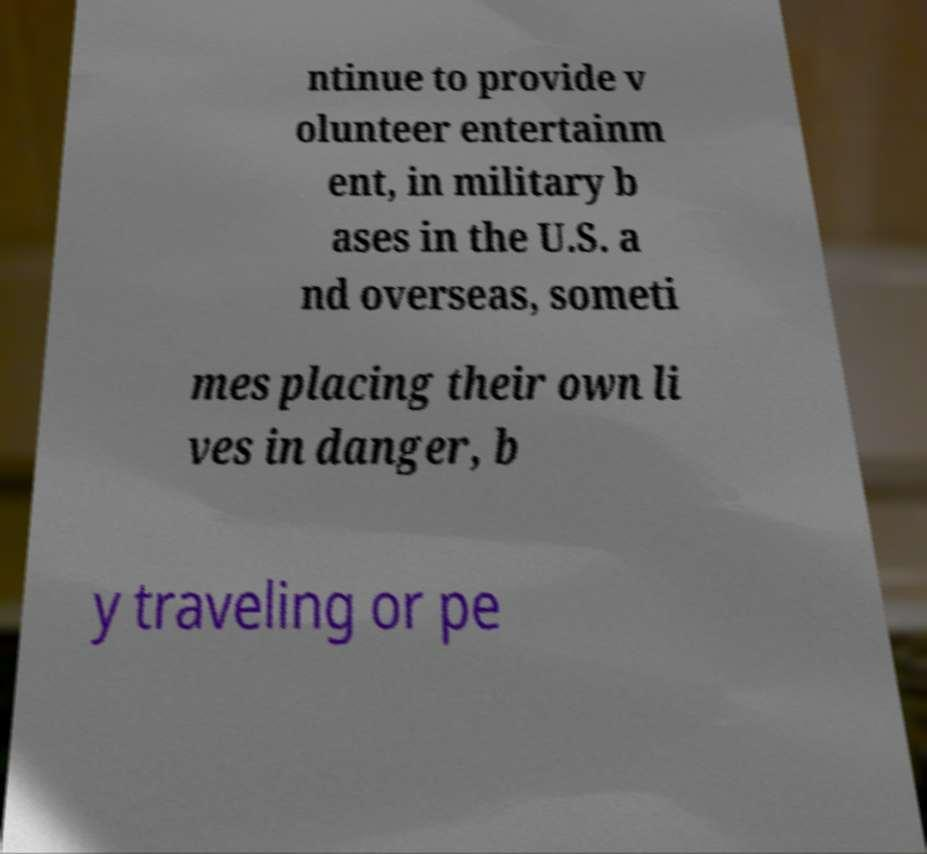Can you accurately transcribe the text from the provided image for me? ntinue to provide v olunteer entertainm ent, in military b ases in the U.S. a nd overseas, someti mes placing their own li ves in danger, b y traveling or pe 